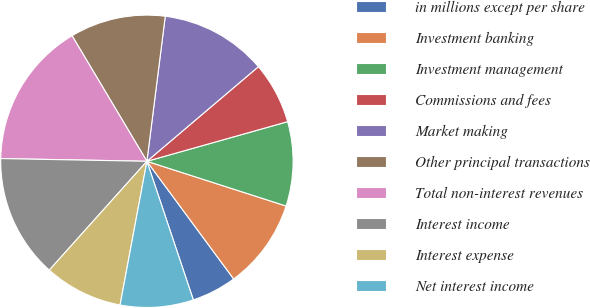<chart> <loc_0><loc_0><loc_500><loc_500><pie_chart><fcel>in millions except per share<fcel>Investment banking<fcel>Investment management<fcel>Commissions and fees<fcel>Market making<fcel>Other principal transactions<fcel>Total non-interest revenues<fcel>Interest income<fcel>Interest expense<fcel>Net interest income<nl><fcel>4.97%<fcel>9.94%<fcel>9.32%<fcel>6.83%<fcel>11.8%<fcel>10.56%<fcel>16.15%<fcel>13.66%<fcel>8.7%<fcel>8.08%<nl></chart> 